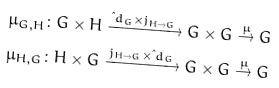Convert formula to latex. <formula><loc_0><loc_0><loc_500><loc_500>\mu _ { G , H } & \colon G \times H \xrightarrow { \i d _ { G } \times j _ { H \to G } } G \times G \stackrel { \mu } { \to } G \\ \mu _ { H , G } & \colon H \times G \xrightarrow { j _ { H \to G } \times \i d _ { G } } G \times G \stackrel { \mu } { \to } G</formula> 